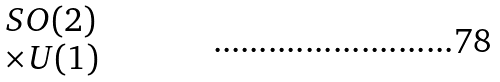<formula> <loc_0><loc_0><loc_500><loc_500>\begin{matrix} S O ( 2 ) \\ \times U ( 1 ) \end{matrix}</formula> 